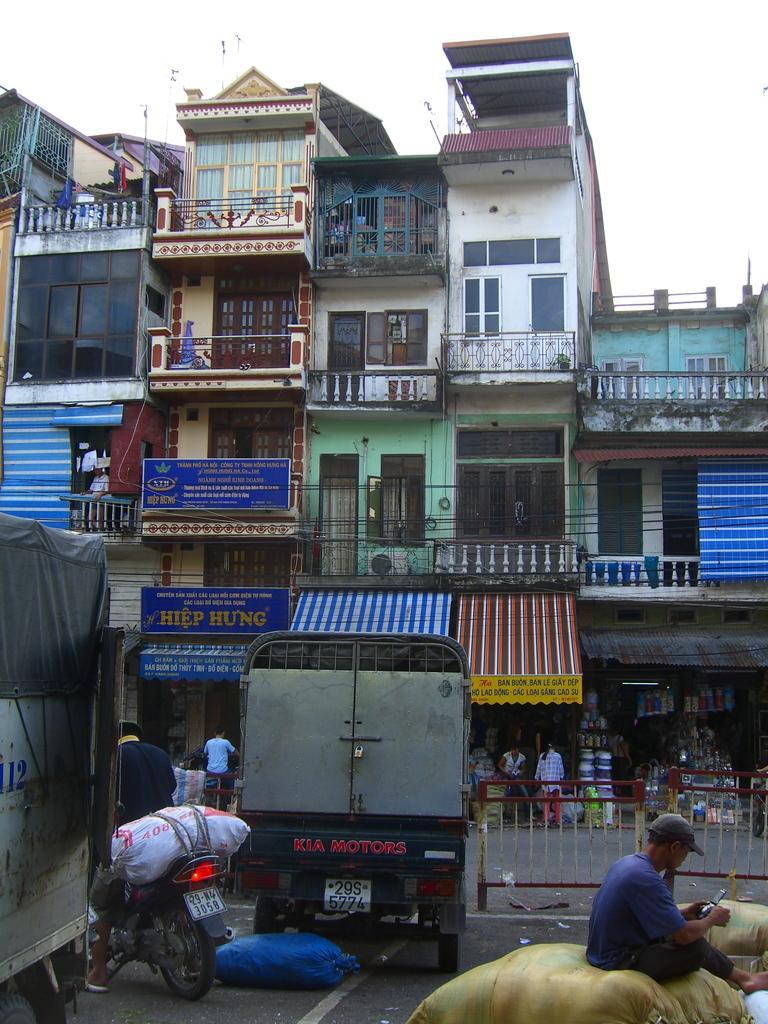In one or two sentences, can you explain what this image depicts? Here we can see few buildings. These are hoarding boards and these are stores. Here we can see vehicles on the road. We can see one man wearing a blue colour t shirt ,wearing a cap sitting on a yellow colour bag. At the top of the picture we can see sky. 